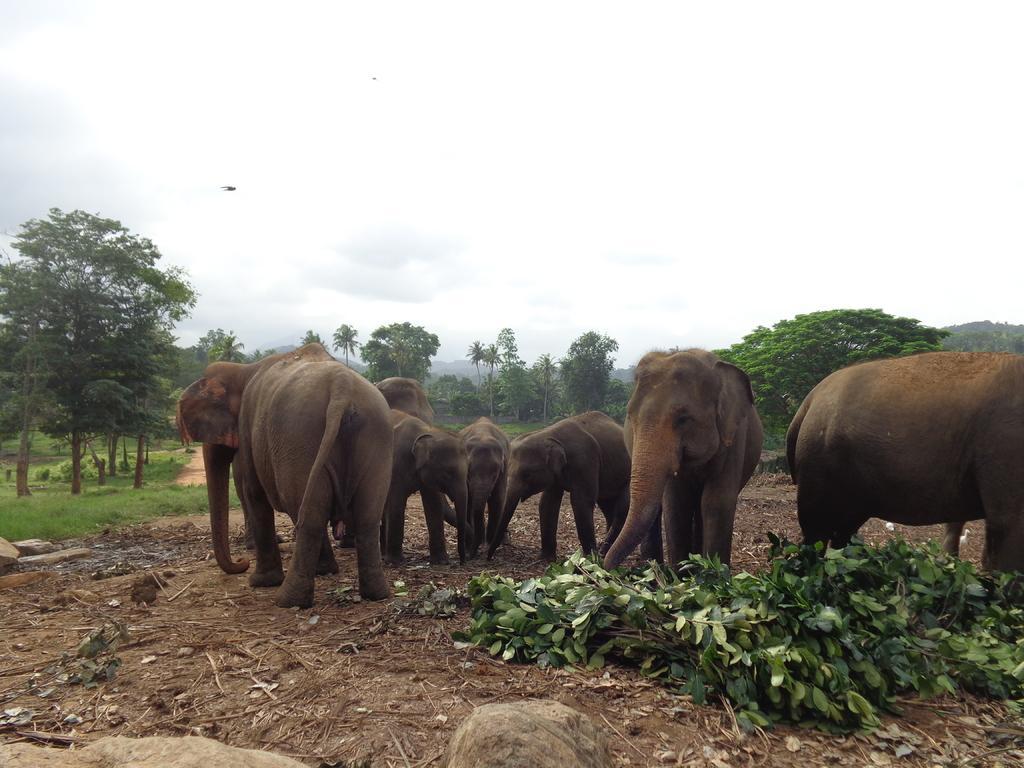How would you summarize this image in a sentence or two? In this image, we can see some trees and elephants. There are leaves on the ground. There is a sky at the top of the image. 